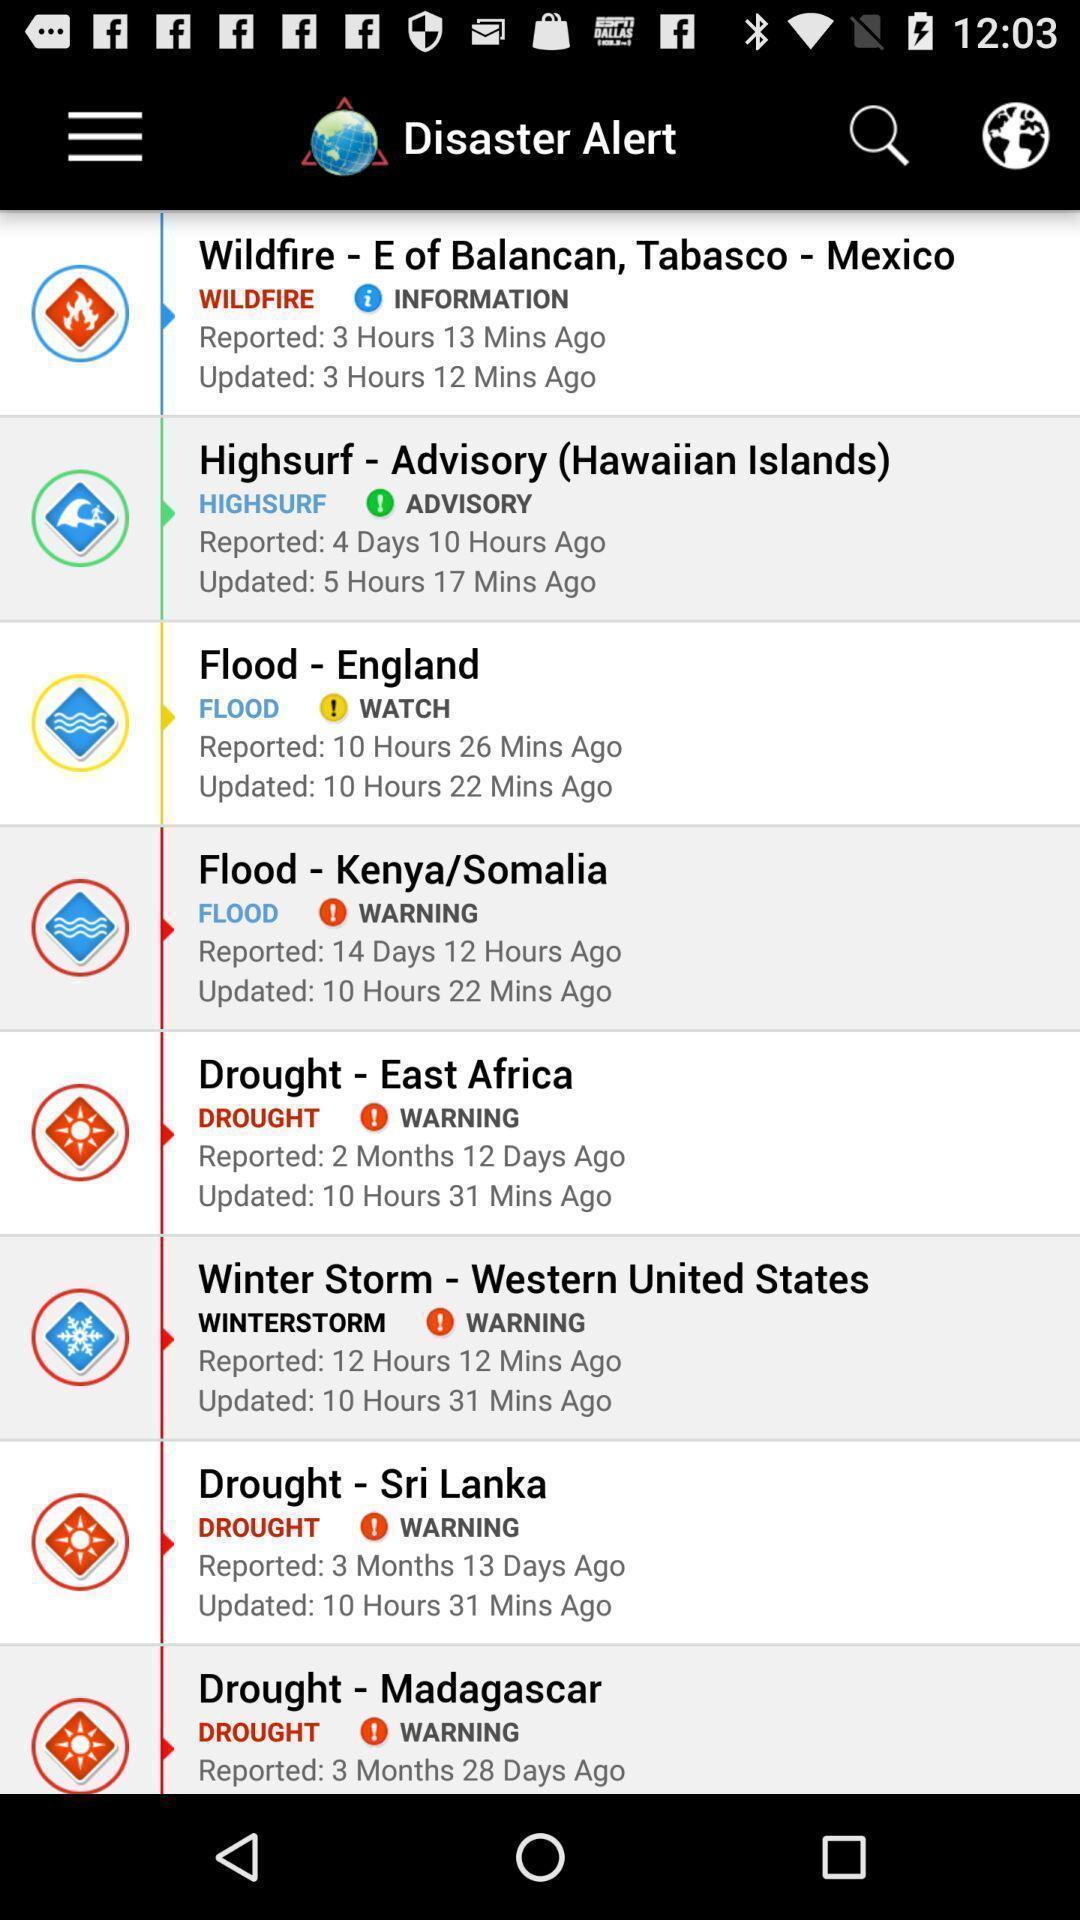Provide a textual representation of this image. Screen displaying multiple natural disaster names in different locations. 